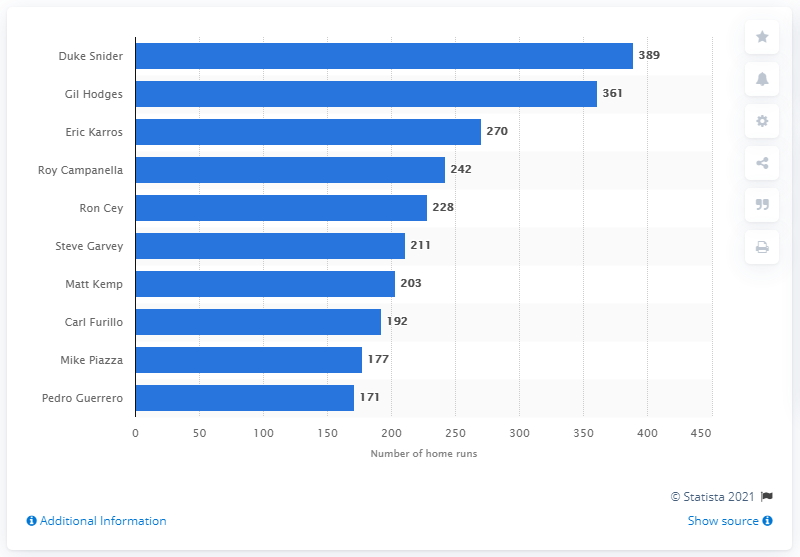Specify some key components in this picture. Duke Snider, the most prolific home run hitter in the history of the Los Angeles Dodgers franchise, struck an impressive total of hits. Duke Snider, a renowned baseball player, has hit a grand total of 389 home runs throughout his illustrious career. 